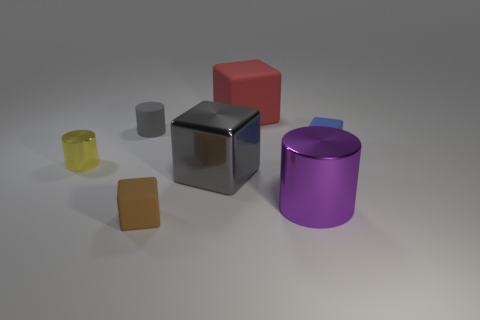Is there anything else that has the same material as the blue block?
Offer a very short reply. Yes. What number of tiny green cylinders are there?
Your response must be concise. 0. What number of objects are tiny gray rubber objects or tiny green blocks?
Provide a short and direct response. 1. There is a object that is the same color as the matte cylinder; what size is it?
Your answer should be very brief. Large. Are there any tiny matte things in front of the big metal cylinder?
Provide a short and direct response. Yes. Is the number of small metal cylinders that are to the left of the tiny gray rubber cylinder greater than the number of small yellow shiny cylinders that are on the right side of the large matte cube?
Make the answer very short. Yes. What is the size of the yellow thing that is the same shape as the small gray matte thing?
Make the answer very short. Small. What number of cubes are small brown objects or yellow metal objects?
Your answer should be very brief. 1. There is a thing that is the same color as the tiny matte cylinder; what is it made of?
Give a very brief answer. Metal. Is the number of large purple metal cylinders in front of the large cylinder less than the number of tiny cubes that are behind the small gray matte cylinder?
Provide a succinct answer. No. 